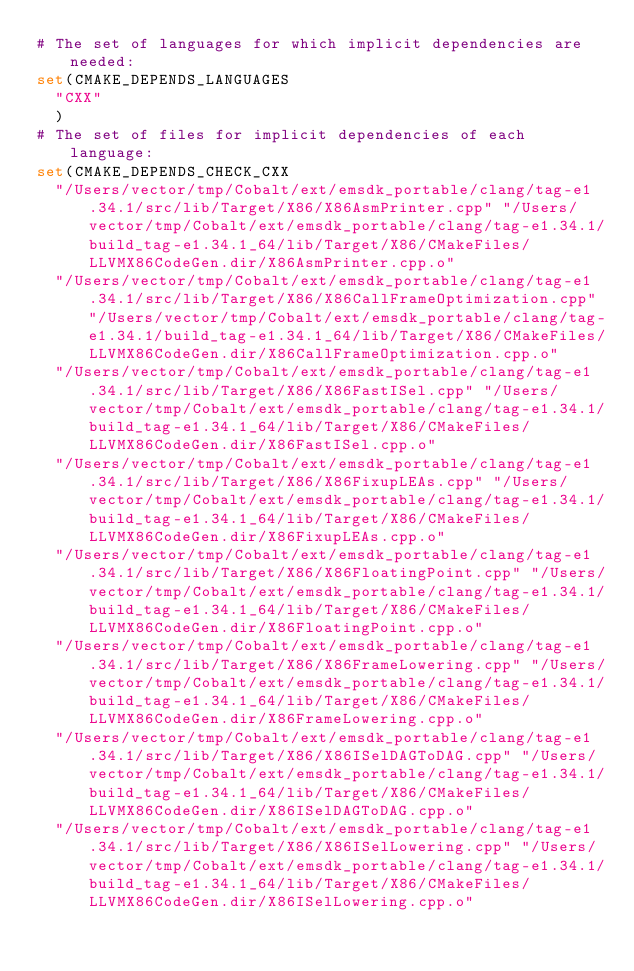<code> <loc_0><loc_0><loc_500><loc_500><_CMake_># The set of languages for which implicit dependencies are needed:
set(CMAKE_DEPENDS_LANGUAGES
  "CXX"
  )
# The set of files for implicit dependencies of each language:
set(CMAKE_DEPENDS_CHECK_CXX
  "/Users/vector/tmp/Cobalt/ext/emsdk_portable/clang/tag-e1.34.1/src/lib/Target/X86/X86AsmPrinter.cpp" "/Users/vector/tmp/Cobalt/ext/emsdk_portable/clang/tag-e1.34.1/build_tag-e1.34.1_64/lib/Target/X86/CMakeFiles/LLVMX86CodeGen.dir/X86AsmPrinter.cpp.o"
  "/Users/vector/tmp/Cobalt/ext/emsdk_portable/clang/tag-e1.34.1/src/lib/Target/X86/X86CallFrameOptimization.cpp" "/Users/vector/tmp/Cobalt/ext/emsdk_portable/clang/tag-e1.34.1/build_tag-e1.34.1_64/lib/Target/X86/CMakeFiles/LLVMX86CodeGen.dir/X86CallFrameOptimization.cpp.o"
  "/Users/vector/tmp/Cobalt/ext/emsdk_portable/clang/tag-e1.34.1/src/lib/Target/X86/X86FastISel.cpp" "/Users/vector/tmp/Cobalt/ext/emsdk_portable/clang/tag-e1.34.1/build_tag-e1.34.1_64/lib/Target/X86/CMakeFiles/LLVMX86CodeGen.dir/X86FastISel.cpp.o"
  "/Users/vector/tmp/Cobalt/ext/emsdk_portable/clang/tag-e1.34.1/src/lib/Target/X86/X86FixupLEAs.cpp" "/Users/vector/tmp/Cobalt/ext/emsdk_portable/clang/tag-e1.34.1/build_tag-e1.34.1_64/lib/Target/X86/CMakeFiles/LLVMX86CodeGen.dir/X86FixupLEAs.cpp.o"
  "/Users/vector/tmp/Cobalt/ext/emsdk_portable/clang/tag-e1.34.1/src/lib/Target/X86/X86FloatingPoint.cpp" "/Users/vector/tmp/Cobalt/ext/emsdk_portable/clang/tag-e1.34.1/build_tag-e1.34.1_64/lib/Target/X86/CMakeFiles/LLVMX86CodeGen.dir/X86FloatingPoint.cpp.o"
  "/Users/vector/tmp/Cobalt/ext/emsdk_portable/clang/tag-e1.34.1/src/lib/Target/X86/X86FrameLowering.cpp" "/Users/vector/tmp/Cobalt/ext/emsdk_portable/clang/tag-e1.34.1/build_tag-e1.34.1_64/lib/Target/X86/CMakeFiles/LLVMX86CodeGen.dir/X86FrameLowering.cpp.o"
  "/Users/vector/tmp/Cobalt/ext/emsdk_portable/clang/tag-e1.34.1/src/lib/Target/X86/X86ISelDAGToDAG.cpp" "/Users/vector/tmp/Cobalt/ext/emsdk_portable/clang/tag-e1.34.1/build_tag-e1.34.1_64/lib/Target/X86/CMakeFiles/LLVMX86CodeGen.dir/X86ISelDAGToDAG.cpp.o"
  "/Users/vector/tmp/Cobalt/ext/emsdk_portable/clang/tag-e1.34.1/src/lib/Target/X86/X86ISelLowering.cpp" "/Users/vector/tmp/Cobalt/ext/emsdk_portable/clang/tag-e1.34.1/build_tag-e1.34.1_64/lib/Target/X86/CMakeFiles/LLVMX86CodeGen.dir/X86ISelLowering.cpp.o"</code> 